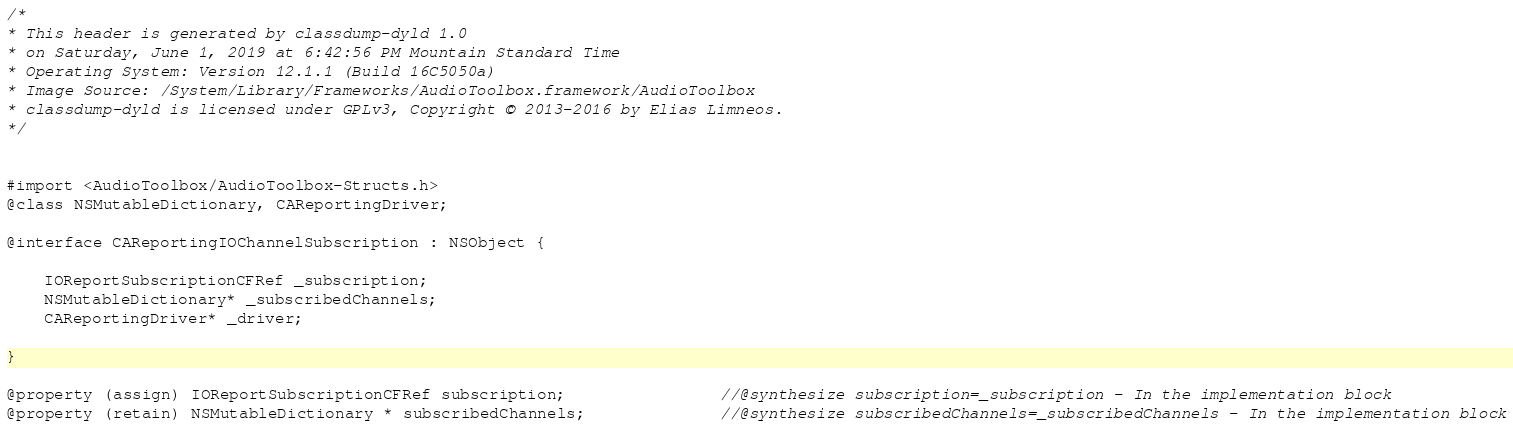Convert code to text. <code><loc_0><loc_0><loc_500><loc_500><_C_>/*
* This header is generated by classdump-dyld 1.0
* on Saturday, June 1, 2019 at 6:42:56 PM Mountain Standard Time
* Operating System: Version 12.1.1 (Build 16C5050a)
* Image Source: /System/Library/Frameworks/AudioToolbox.framework/AudioToolbox
* classdump-dyld is licensed under GPLv3, Copyright © 2013-2016 by Elias Limneos.
*/


#import <AudioToolbox/AudioToolbox-Structs.h>
@class NSMutableDictionary, CAReportingDriver;

@interface CAReportingIOChannelSubscription : NSObject {

	IOReportSubscriptionCFRef _subscription;
	NSMutableDictionary* _subscribedChannels;
	CAReportingDriver* _driver;

}

@property (assign) IOReportSubscriptionCFRef subscription;                //@synthesize subscription=_subscription - In the implementation block
@property (retain) NSMutableDictionary * subscribedChannels;              //@synthesize subscribedChannels=_subscribedChannels - In the implementation block</code> 